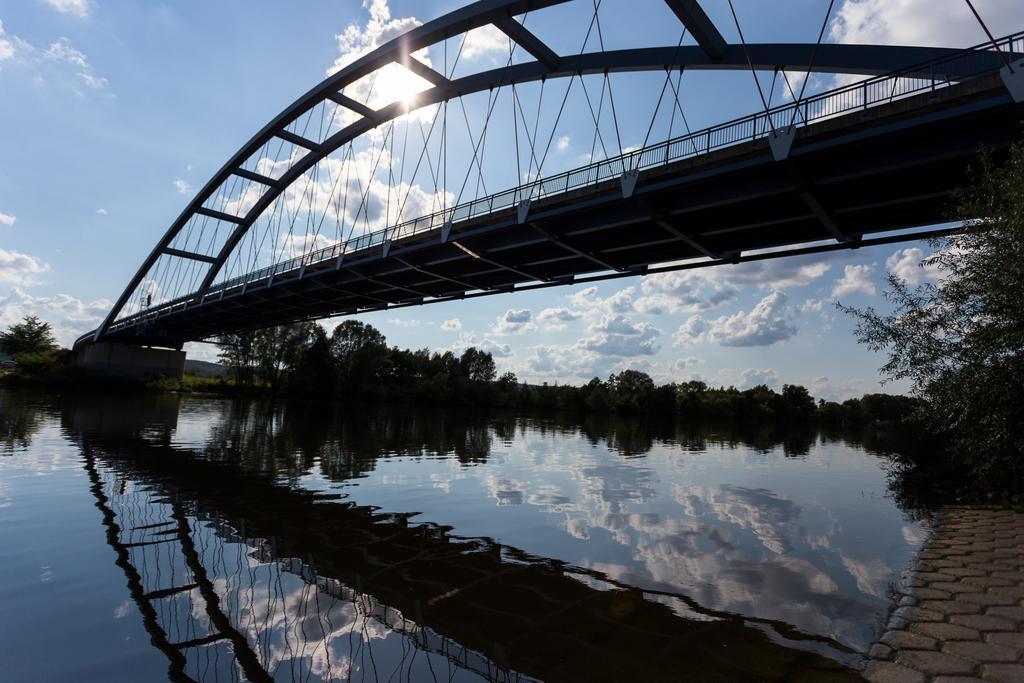Can you describe this image briefly? In the picture I can see a bridge, the water, trees and some other objects. In the background I can see the sun and the sky. 